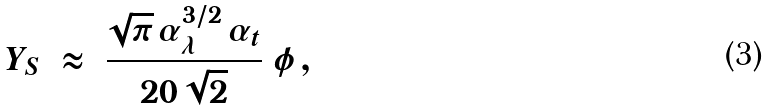<formula> <loc_0><loc_0><loc_500><loc_500>Y _ { S } \ \approx \ \frac { \sqrt { \pi } \, \alpha _ { \lambda } ^ { 3 / 2 } \, \alpha _ { t } } { 2 0 \, \sqrt { 2 } } \ \phi \, ,</formula> 